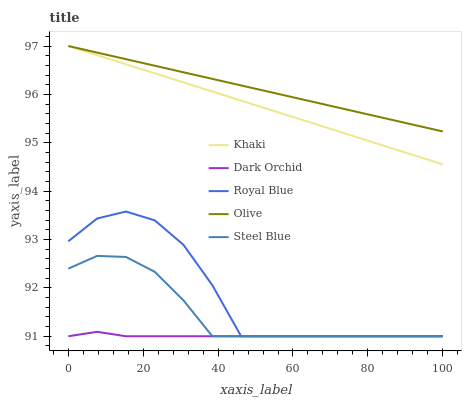Does Dark Orchid have the minimum area under the curve?
Answer yes or no. Yes. Does Olive have the maximum area under the curve?
Answer yes or no. Yes. Does Royal Blue have the minimum area under the curve?
Answer yes or no. No. Does Royal Blue have the maximum area under the curve?
Answer yes or no. No. Is Khaki the smoothest?
Answer yes or no. Yes. Is Royal Blue the roughest?
Answer yes or no. Yes. Is Royal Blue the smoothest?
Answer yes or no. No. Is Khaki the roughest?
Answer yes or no. No. Does Royal Blue have the lowest value?
Answer yes or no. Yes. Does Khaki have the lowest value?
Answer yes or no. No. Does Khaki have the highest value?
Answer yes or no. Yes. Does Royal Blue have the highest value?
Answer yes or no. No. Is Steel Blue less than Olive?
Answer yes or no. Yes. Is Khaki greater than Dark Orchid?
Answer yes or no. Yes. Does Dark Orchid intersect Royal Blue?
Answer yes or no. Yes. Is Dark Orchid less than Royal Blue?
Answer yes or no. No. Is Dark Orchid greater than Royal Blue?
Answer yes or no. No. Does Steel Blue intersect Olive?
Answer yes or no. No. 